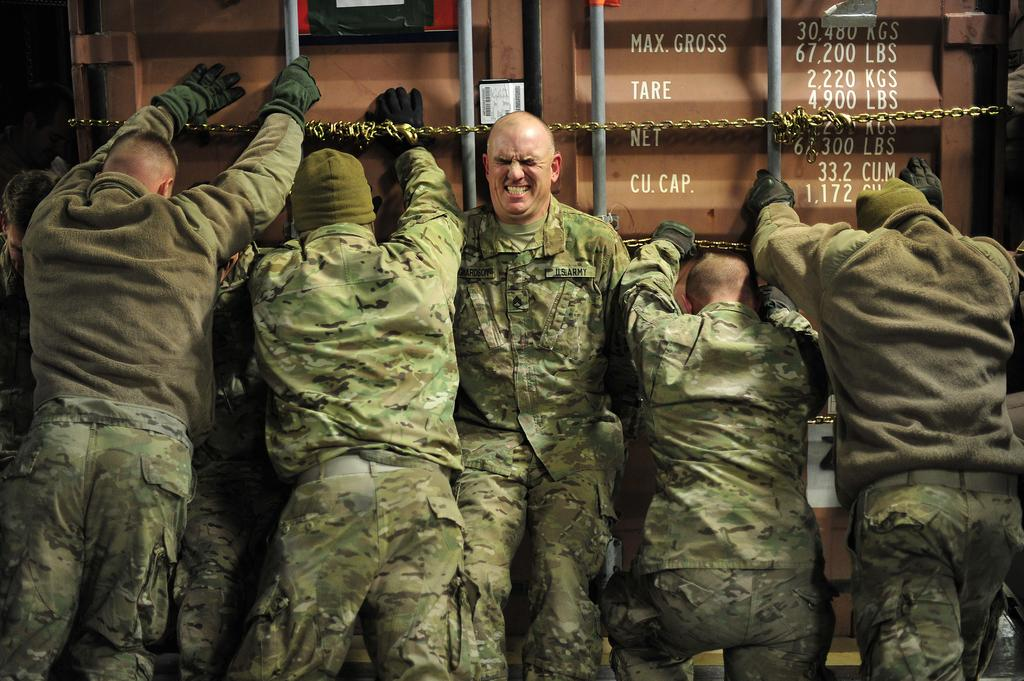How many people are in the image? There are five men in the image. What are the men doing in the image? The men are pushing a door of a truck. What type of clothing are the men wearing? The men are wearing army uniforms. Who is the creator of the wax pear in the image? There is no wax pear present in the image, so it is not possible to determine who created it. 